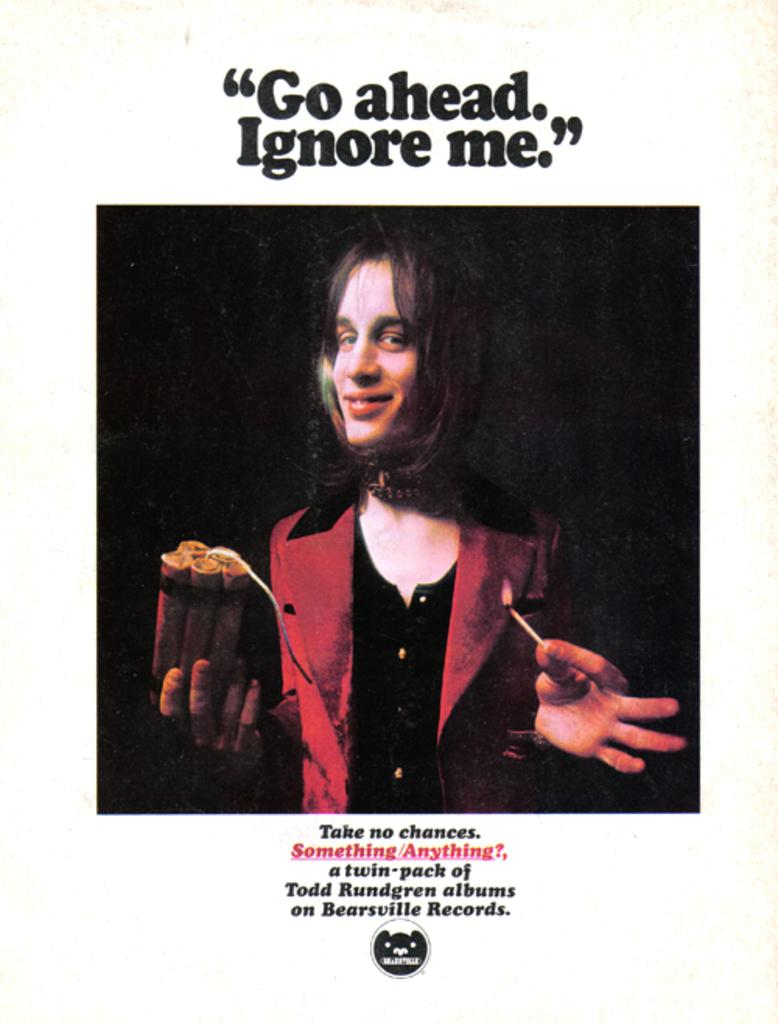Who or what is in the center of the image? There is a person in the center of the image. What is the person holding in the image? The person is holding a bomb. Where can text be found in the image? There is text at the bottom and top of the image. Is there a faucet visible in the image? No, there is no faucet present in the image. What type of fire can be seen in the image? There is no fire present in the image. 